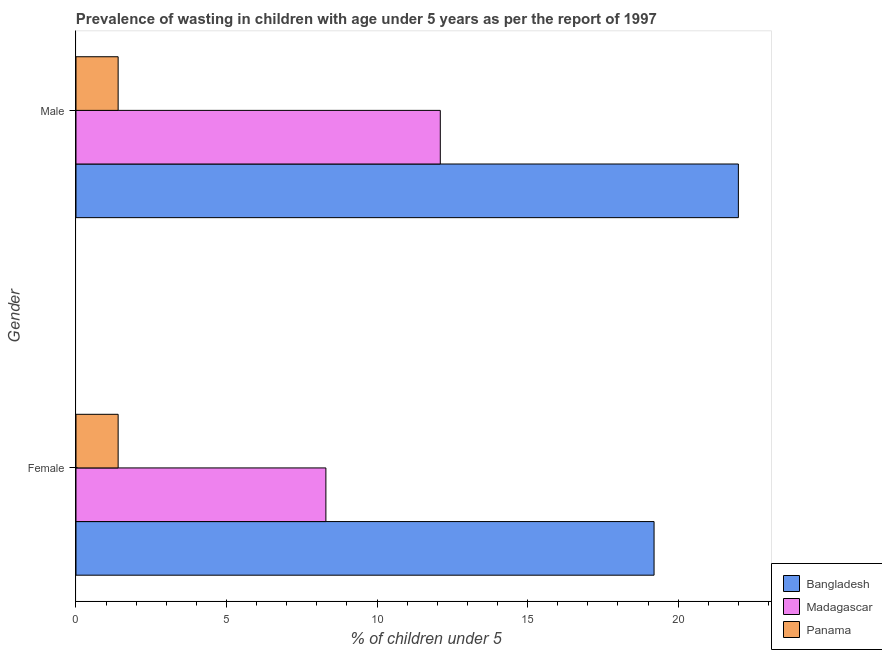Are the number of bars per tick equal to the number of legend labels?
Make the answer very short. Yes. How many bars are there on the 1st tick from the top?
Provide a succinct answer. 3. What is the percentage of undernourished female children in Panama?
Offer a very short reply. 1.4. Across all countries, what is the maximum percentage of undernourished female children?
Keep it short and to the point. 19.2. Across all countries, what is the minimum percentage of undernourished female children?
Your response must be concise. 1.4. In which country was the percentage of undernourished female children maximum?
Your answer should be very brief. Bangladesh. In which country was the percentage of undernourished male children minimum?
Ensure brevity in your answer.  Panama. What is the total percentage of undernourished male children in the graph?
Make the answer very short. 35.5. What is the difference between the percentage of undernourished male children in Bangladesh and that in Madagascar?
Provide a short and direct response. 9.9. What is the difference between the percentage of undernourished male children in Panama and the percentage of undernourished female children in Bangladesh?
Offer a very short reply. -17.8. What is the average percentage of undernourished female children per country?
Give a very brief answer. 9.63. What is the difference between the percentage of undernourished male children and percentage of undernourished female children in Madagascar?
Provide a succinct answer. 3.8. In how many countries, is the percentage of undernourished female children greater than 13 %?
Your answer should be compact. 1. What is the ratio of the percentage of undernourished male children in Panama to that in Bangladesh?
Keep it short and to the point. 0.06. Is the percentage of undernourished female children in Madagascar less than that in Bangladesh?
Offer a terse response. Yes. How many bars are there?
Offer a very short reply. 6. Are the values on the major ticks of X-axis written in scientific E-notation?
Keep it short and to the point. No. Where does the legend appear in the graph?
Provide a succinct answer. Bottom right. How are the legend labels stacked?
Your answer should be very brief. Vertical. What is the title of the graph?
Your answer should be compact. Prevalence of wasting in children with age under 5 years as per the report of 1997. Does "American Samoa" appear as one of the legend labels in the graph?
Provide a succinct answer. No. What is the label or title of the X-axis?
Your response must be concise.  % of children under 5. What is the label or title of the Y-axis?
Your response must be concise. Gender. What is the  % of children under 5 of Bangladesh in Female?
Give a very brief answer. 19.2. What is the  % of children under 5 in Madagascar in Female?
Offer a terse response. 8.3. What is the  % of children under 5 in Panama in Female?
Offer a terse response. 1.4. What is the  % of children under 5 in Bangladesh in Male?
Offer a very short reply. 22. What is the  % of children under 5 of Madagascar in Male?
Give a very brief answer. 12.1. What is the  % of children under 5 of Panama in Male?
Your answer should be compact. 1.4. Across all Gender, what is the maximum  % of children under 5 of Bangladesh?
Provide a short and direct response. 22. Across all Gender, what is the maximum  % of children under 5 of Madagascar?
Make the answer very short. 12.1. Across all Gender, what is the maximum  % of children under 5 of Panama?
Offer a very short reply. 1.4. Across all Gender, what is the minimum  % of children under 5 in Bangladesh?
Give a very brief answer. 19.2. Across all Gender, what is the minimum  % of children under 5 in Madagascar?
Ensure brevity in your answer.  8.3. Across all Gender, what is the minimum  % of children under 5 in Panama?
Provide a succinct answer. 1.4. What is the total  % of children under 5 in Bangladesh in the graph?
Keep it short and to the point. 41.2. What is the total  % of children under 5 in Madagascar in the graph?
Offer a terse response. 20.4. What is the difference between the  % of children under 5 of Madagascar in Female and that in Male?
Your answer should be very brief. -3.8. What is the difference between the  % of children under 5 in Bangladesh in Female and the  % of children under 5 in Panama in Male?
Provide a short and direct response. 17.8. What is the difference between the  % of children under 5 of Madagascar in Female and the  % of children under 5 of Panama in Male?
Ensure brevity in your answer.  6.9. What is the average  % of children under 5 of Bangladesh per Gender?
Offer a terse response. 20.6. What is the average  % of children under 5 of Madagascar per Gender?
Provide a short and direct response. 10.2. What is the average  % of children under 5 of Panama per Gender?
Make the answer very short. 1.4. What is the difference between the  % of children under 5 of Bangladesh and  % of children under 5 of Panama in Male?
Make the answer very short. 20.6. What is the ratio of the  % of children under 5 in Bangladesh in Female to that in Male?
Make the answer very short. 0.87. What is the ratio of the  % of children under 5 of Madagascar in Female to that in Male?
Offer a very short reply. 0.69. What is the ratio of the  % of children under 5 of Panama in Female to that in Male?
Your answer should be very brief. 1. What is the difference between the highest and the second highest  % of children under 5 in Bangladesh?
Provide a succinct answer. 2.8. What is the difference between the highest and the second highest  % of children under 5 in Panama?
Give a very brief answer. 0. What is the difference between the highest and the lowest  % of children under 5 in Bangladesh?
Offer a very short reply. 2.8. What is the difference between the highest and the lowest  % of children under 5 of Panama?
Keep it short and to the point. 0. 